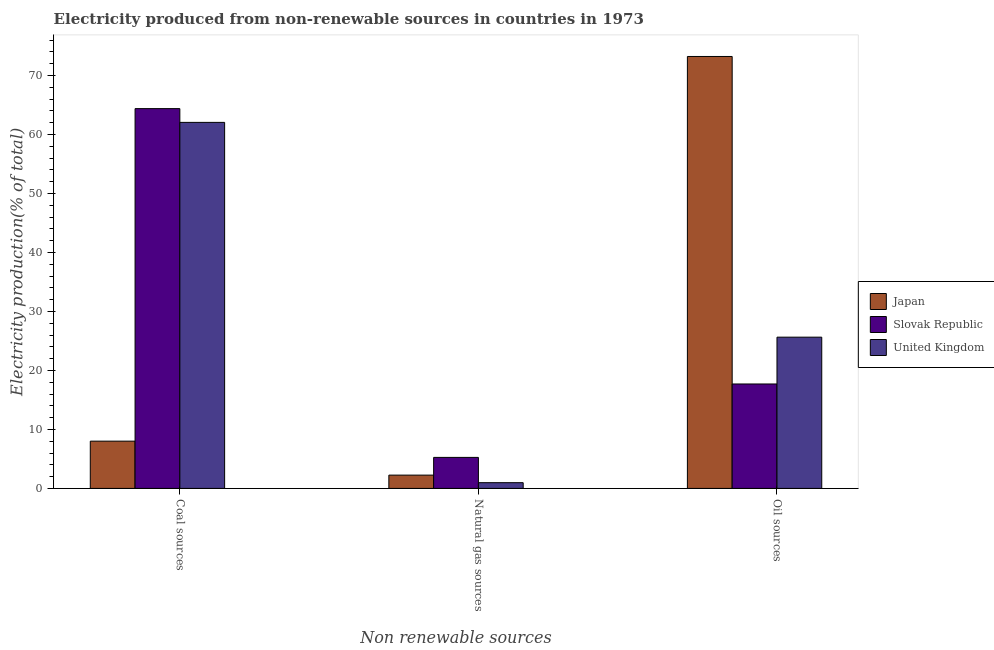Are the number of bars on each tick of the X-axis equal?
Your answer should be very brief. Yes. How many bars are there on the 2nd tick from the right?
Give a very brief answer. 3. What is the label of the 3rd group of bars from the left?
Provide a short and direct response. Oil sources. What is the percentage of electricity produced by coal in Slovak Republic?
Make the answer very short. 64.4. Across all countries, what is the maximum percentage of electricity produced by coal?
Offer a very short reply. 64.4. Across all countries, what is the minimum percentage of electricity produced by natural gas?
Your answer should be very brief. 0.97. In which country was the percentage of electricity produced by natural gas maximum?
Ensure brevity in your answer.  Slovak Republic. In which country was the percentage of electricity produced by oil sources minimum?
Offer a terse response. Slovak Republic. What is the total percentage of electricity produced by natural gas in the graph?
Keep it short and to the point. 8.49. What is the difference between the percentage of electricity produced by natural gas in Japan and that in United Kingdom?
Offer a terse response. 1.28. What is the difference between the percentage of electricity produced by oil sources in Slovak Republic and the percentage of electricity produced by natural gas in Japan?
Give a very brief answer. 15.45. What is the average percentage of electricity produced by coal per country?
Make the answer very short. 44.82. What is the difference between the percentage of electricity produced by coal and percentage of electricity produced by oil sources in Slovak Republic?
Make the answer very short. 46.69. In how many countries, is the percentage of electricity produced by coal greater than 18 %?
Provide a succinct answer. 2. What is the ratio of the percentage of electricity produced by natural gas in United Kingdom to that in Japan?
Keep it short and to the point. 0.43. Is the percentage of electricity produced by natural gas in Slovak Republic less than that in United Kingdom?
Provide a short and direct response. No. Is the difference between the percentage of electricity produced by natural gas in United Kingdom and Slovak Republic greater than the difference between the percentage of electricity produced by coal in United Kingdom and Slovak Republic?
Your answer should be compact. No. What is the difference between the highest and the second highest percentage of electricity produced by coal?
Your answer should be compact. 2.33. What is the difference between the highest and the lowest percentage of electricity produced by oil sources?
Keep it short and to the point. 55.53. Is the sum of the percentage of electricity produced by coal in Slovak Republic and Japan greater than the maximum percentage of electricity produced by oil sources across all countries?
Provide a short and direct response. No. What does the 2nd bar from the left in Coal sources represents?
Provide a short and direct response. Slovak Republic. How many bars are there?
Ensure brevity in your answer.  9. Are all the bars in the graph horizontal?
Your response must be concise. No. How many countries are there in the graph?
Provide a succinct answer. 3. What is the difference between two consecutive major ticks on the Y-axis?
Give a very brief answer. 10. Are the values on the major ticks of Y-axis written in scientific E-notation?
Keep it short and to the point. No. Does the graph contain grids?
Make the answer very short. No. Where does the legend appear in the graph?
Ensure brevity in your answer.  Center right. How are the legend labels stacked?
Make the answer very short. Vertical. What is the title of the graph?
Offer a terse response. Electricity produced from non-renewable sources in countries in 1973. What is the label or title of the X-axis?
Your response must be concise. Non renewable sources. What is the Electricity production(% of total) of Japan in Coal sources?
Make the answer very short. 8.01. What is the Electricity production(% of total) in Slovak Republic in Coal sources?
Your response must be concise. 64.4. What is the Electricity production(% of total) in United Kingdom in Coal sources?
Provide a succinct answer. 62.06. What is the Electricity production(% of total) in Japan in Natural gas sources?
Offer a very short reply. 2.26. What is the Electricity production(% of total) of Slovak Republic in Natural gas sources?
Your answer should be compact. 5.26. What is the Electricity production(% of total) of United Kingdom in Natural gas sources?
Keep it short and to the point. 0.97. What is the Electricity production(% of total) in Japan in Oil sources?
Keep it short and to the point. 73.24. What is the Electricity production(% of total) in Slovak Republic in Oil sources?
Offer a terse response. 17.71. What is the Electricity production(% of total) of United Kingdom in Oil sources?
Offer a terse response. 25.65. Across all Non renewable sources, what is the maximum Electricity production(% of total) in Japan?
Ensure brevity in your answer.  73.24. Across all Non renewable sources, what is the maximum Electricity production(% of total) in Slovak Republic?
Offer a very short reply. 64.4. Across all Non renewable sources, what is the maximum Electricity production(% of total) in United Kingdom?
Provide a succinct answer. 62.06. Across all Non renewable sources, what is the minimum Electricity production(% of total) in Japan?
Your response must be concise. 2.26. Across all Non renewable sources, what is the minimum Electricity production(% of total) of Slovak Republic?
Your answer should be very brief. 5.26. Across all Non renewable sources, what is the minimum Electricity production(% of total) of United Kingdom?
Provide a succinct answer. 0.97. What is the total Electricity production(% of total) of Japan in the graph?
Ensure brevity in your answer.  83.51. What is the total Electricity production(% of total) of Slovak Republic in the graph?
Offer a very short reply. 87.36. What is the total Electricity production(% of total) in United Kingdom in the graph?
Give a very brief answer. 88.68. What is the difference between the Electricity production(% of total) in Japan in Coal sources and that in Natural gas sources?
Make the answer very short. 5.76. What is the difference between the Electricity production(% of total) in Slovak Republic in Coal sources and that in Natural gas sources?
Offer a terse response. 59.13. What is the difference between the Electricity production(% of total) in United Kingdom in Coal sources and that in Natural gas sources?
Give a very brief answer. 61.09. What is the difference between the Electricity production(% of total) in Japan in Coal sources and that in Oil sources?
Provide a succinct answer. -65.22. What is the difference between the Electricity production(% of total) in Slovak Republic in Coal sources and that in Oil sources?
Your answer should be very brief. 46.69. What is the difference between the Electricity production(% of total) in United Kingdom in Coal sources and that in Oil sources?
Make the answer very short. 36.42. What is the difference between the Electricity production(% of total) of Japan in Natural gas sources and that in Oil sources?
Offer a very short reply. -70.98. What is the difference between the Electricity production(% of total) in Slovak Republic in Natural gas sources and that in Oil sources?
Provide a short and direct response. -12.45. What is the difference between the Electricity production(% of total) of United Kingdom in Natural gas sources and that in Oil sources?
Keep it short and to the point. -24.67. What is the difference between the Electricity production(% of total) of Japan in Coal sources and the Electricity production(% of total) of Slovak Republic in Natural gas sources?
Ensure brevity in your answer.  2.75. What is the difference between the Electricity production(% of total) in Japan in Coal sources and the Electricity production(% of total) in United Kingdom in Natural gas sources?
Your answer should be very brief. 7.04. What is the difference between the Electricity production(% of total) in Slovak Republic in Coal sources and the Electricity production(% of total) in United Kingdom in Natural gas sources?
Offer a very short reply. 63.42. What is the difference between the Electricity production(% of total) of Japan in Coal sources and the Electricity production(% of total) of Slovak Republic in Oil sources?
Keep it short and to the point. -9.69. What is the difference between the Electricity production(% of total) of Japan in Coal sources and the Electricity production(% of total) of United Kingdom in Oil sources?
Ensure brevity in your answer.  -17.63. What is the difference between the Electricity production(% of total) of Slovak Republic in Coal sources and the Electricity production(% of total) of United Kingdom in Oil sources?
Offer a terse response. 38.75. What is the difference between the Electricity production(% of total) of Japan in Natural gas sources and the Electricity production(% of total) of Slovak Republic in Oil sources?
Offer a terse response. -15.45. What is the difference between the Electricity production(% of total) of Japan in Natural gas sources and the Electricity production(% of total) of United Kingdom in Oil sources?
Make the answer very short. -23.39. What is the difference between the Electricity production(% of total) of Slovak Republic in Natural gas sources and the Electricity production(% of total) of United Kingdom in Oil sources?
Your response must be concise. -20.38. What is the average Electricity production(% of total) of Japan per Non renewable sources?
Keep it short and to the point. 27.84. What is the average Electricity production(% of total) of Slovak Republic per Non renewable sources?
Offer a very short reply. 29.12. What is the average Electricity production(% of total) in United Kingdom per Non renewable sources?
Give a very brief answer. 29.56. What is the difference between the Electricity production(% of total) of Japan and Electricity production(% of total) of Slovak Republic in Coal sources?
Offer a terse response. -56.38. What is the difference between the Electricity production(% of total) of Japan and Electricity production(% of total) of United Kingdom in Coal sources?
Offer a very short reply. -54.05. What is the difference between the Electricity production(% of total) of Slovak Republic and Electricity production(% of total) of United Kingdom in Coal sources?
Your answer should be very brief. 2.33. What is the difference between the Electricity production(% of total) of Japan and Electricity production(% of total) of Slovak Republic in Natural gas sources?
Provide a short and direct response. -3. What is the difference between the Electricity production(% of total) in Japan and Electricity production(% of total) in United Kingdom in Natural gas sources?
Your response must be concise. 1.28. What is the difference between the Electricity production(% of total) in Slovak Republic and Electricity production(% of total) in United Kingdom in Natural gas sources?
Keep it short and to the point. 4.29. What is the difference between the Electricity production(% of total) of Japan and Electricity production(% of total) of Slovak Republic in Oil sources?
Your answer should be very brief. 55.53. What is the difference between the Electricity production(% of total) in Japan and Electricity production(% of total) in United Kingdom in Oil sources?
Make the answer very short. 47.59. What is the difference between the Electricity production(% of total) in Slovak Republic and Electricity production(% of total) in United Kingdom in Oil sources?
Your answer should be compact. -7.94. What is the ratio of the Electricity production(% of total) of Japan in Coal sources to that in Natural gas sources?
Your answer should be compact. 3.55. What is the ratio of the Electricity production(% of total) in Slovak Republic in Coal sources to that in Natural gas sources?
Provide a short and direct response. 12.24. What is the ratio of the Electricity production(% of total) of United Kingdom in Coal sources to that in Natural gas sources?
Offer a terse response. 63.84. What is the ratio of the Electricity production(% of total) of Japan in Coal sources to that in Oil sources?
Make the answer very short. 0.11. What is the ratio of the Electricity production(% of total) of Slovak Republic in Coal sources to that in Oil sources?
Your response must be concise. 3.64. What is the ratio of the Electricity production(% of total) in United Kingdom in Coal sources to that in Oil sources?
Your answer should be very brief. 2.42. What is the ratio of the Electricity production(% of total) in Japan in Natural gas sources to that in Oil sources?
Your answer should be compact. 0.03. What is the ratio of the Electricity production(% of total) of Slovak Republic in Natural gas sources to that in Oil sources?
Give a very brief answer. 0.3. What is the ratio of the Electricity production(% of total) of United Kingdom in Natural gas sources to that in Oil sources?
Provide a succinct answer. 0.04. What is the difference between the highest and the second highest Electricity production(% of total) of Japan?
Offer a terse response. 65.22. What is the difference between the highest and the second highest Electricity production(% of total) of Slovak Republic?
Ensure brevity in your answer.  46.69. What is the difference between the highest and the second highest Electricity production(% of total) in United Kingdom?
Your response must be concise. 36.42. What is the difference between the highest and the lowest Electricity production(% of total) in Japan?
Ensure brevity in your answer.  70.98. What is the difference between the highest and the lowest Electricity production(% of total) of Slovak Republic?
Your answer should be very brief. 59.13. What is the difference between the highest and the lowest Electricity production(% of total) of United Kingdom?
Offer a terse response. 61.09. 